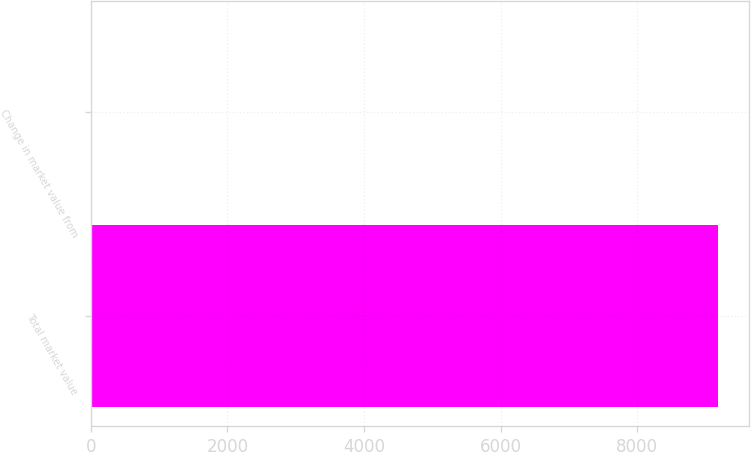<chart> <loc_0><loc_0><loc_500><loc_500><bar_chart><fcel>Total market value<fcel>Change in market value from<nl><fcel>9178<fcel>3.36<nl></chart> 